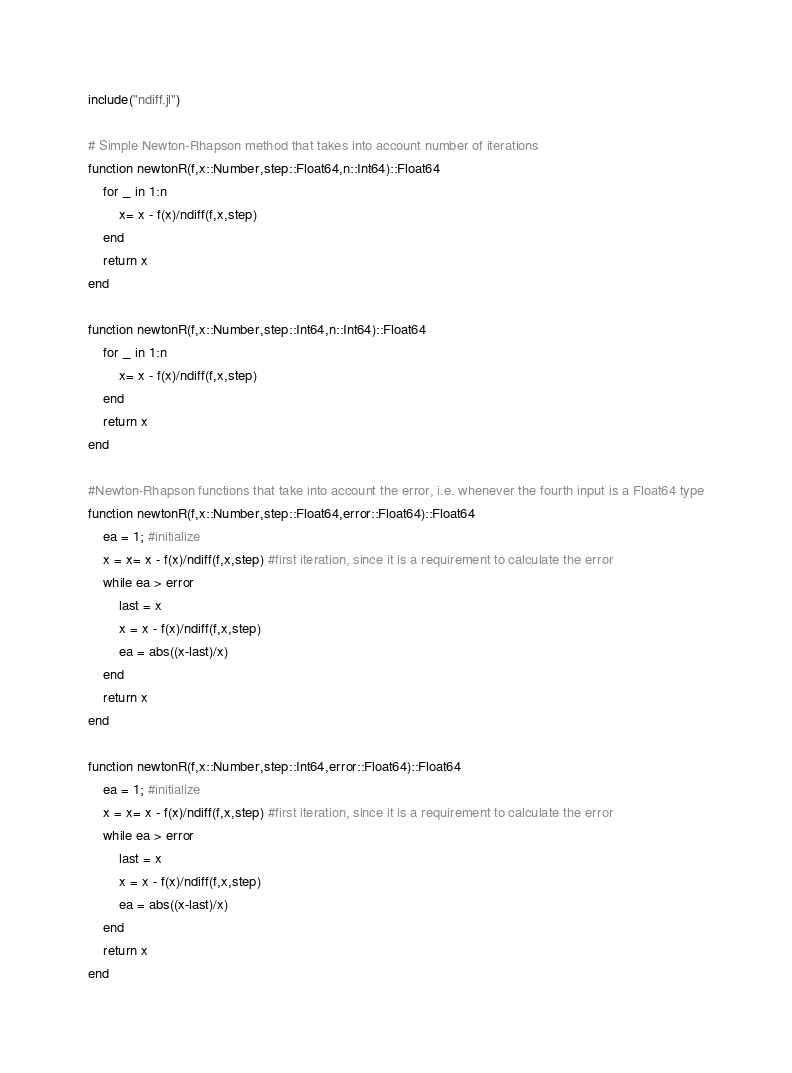Convert code to text. <code><loc_0><loc_0><loc_500><loc_500><_Julia_>include("ndiff.jl")

# Simple Newton-Rhapson method that takes into account number of iterations
function newtonR(f,x::Number,step::Float64,n::Int64)::Float64
    for _ in 1:n
        x= x - f(x)/ndiff(f,x,step)
    end
    return x
end

function newtonR(f,x::Number,step::Int64,n::Int64)::Float64
    for _ in 1:n
        x= x - f(x)/ndiff(f,x,step)
    end
    return x
end

#Newton-Rhapson functions that take into account the error, i.e. whenever the fourth input is a Float64 type
function newtonR(f,x::Number,step::Float64,error::Float64)::Float64
    ea = 1; #initialize
    x = x= x - f(x)/ndiff(f,x,step) #first iteration, since it is a requirement to calculate the error
    while ea > error
        last = x
        x = x - f(x)/ndiff(f,x,step)
        ea = abs((x-last)/x)
    end
    return x
end

function newtonR(f,x::Number,step::Int64,error::Float64)::Float64
    ea = 1; #initialize
    x = x= x - f(x)/ndiff(f,x,step) #first iteration, since it is a requirement to calculate the error
    while ea > error
        last = x
        x = x - f(x)/ndiff(f,x,step)
        ea = abs((x-last)/x)
    end
    return x
end
</code> 